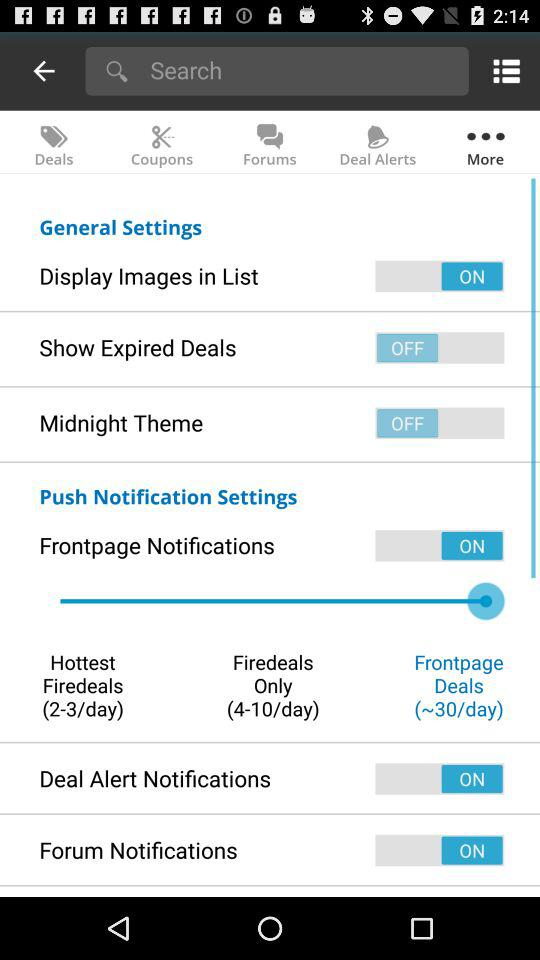How many forum notifications are there per day?
When the provided information is insufficient, respond with <no answer>. <no answer> 